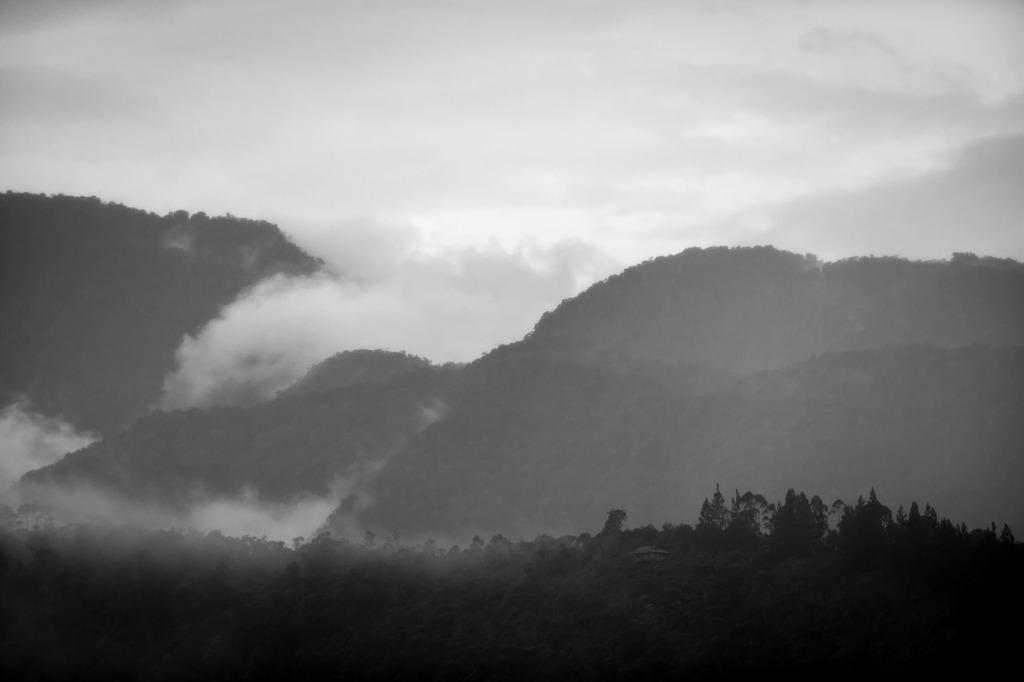What is the color scheme of the image? The image is black and white. What type of natural elements can be seen in the image? There are trees and hills visible in the image. What is the weather condition in the image? The sky in the background is cloudy. What else can be seen in the image? There is smoke visible in the image. What type of scissors are being used to cut the songs in the image? There are no scissors or songs present in the image. What is the base of the trees in the image? The provided facts do not mention the base of the trees, so we cannot answer that question definitively. 